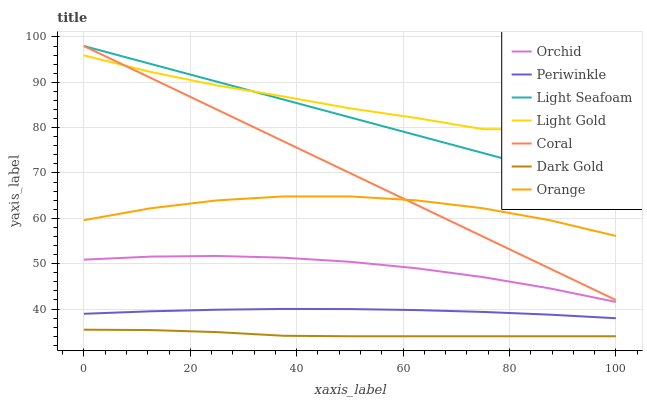Does Coral have the minimum area under the curve?
Answer yes or no. No. Does Coral have the maximum area under the curve?
Answer yes or no. No. Is Periwinkle the smoothest?
Answer yes or no. No. Is Periwinkle the roughest?
Answer yes or no. No. Does Coral have the lowest value?
Answer yes or no. No. Does Periwinkle have the highest value?
Answer yes or no. No. Is Dark Gold less than Orchid?
Answer yes or no. Yes. Is Coral greater than Periwinkle?
Answer yes or no. Yes. Does Dark Gold intersect Orchid?
Answer yes or no. No. 